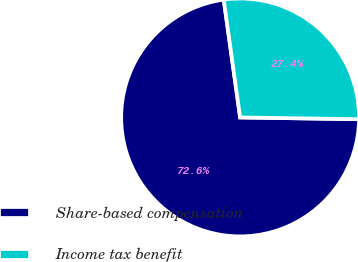Convert chart to OTSL. <chart><loc_0><loc_0><loc_500><loc_500><pie_chart><fcel>Share-based compensation<fcel>Income tax benefit<nl><fcel>72.56%<fcel>27.44%<nl></chart> 